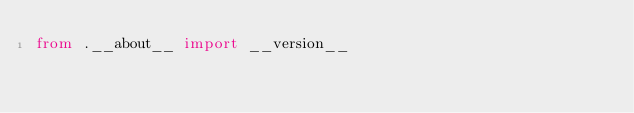Convert code to text. <code><loc_0><loc_0><loc_500><loc_500><_Python_>from .__about__ import __version__
</code> 